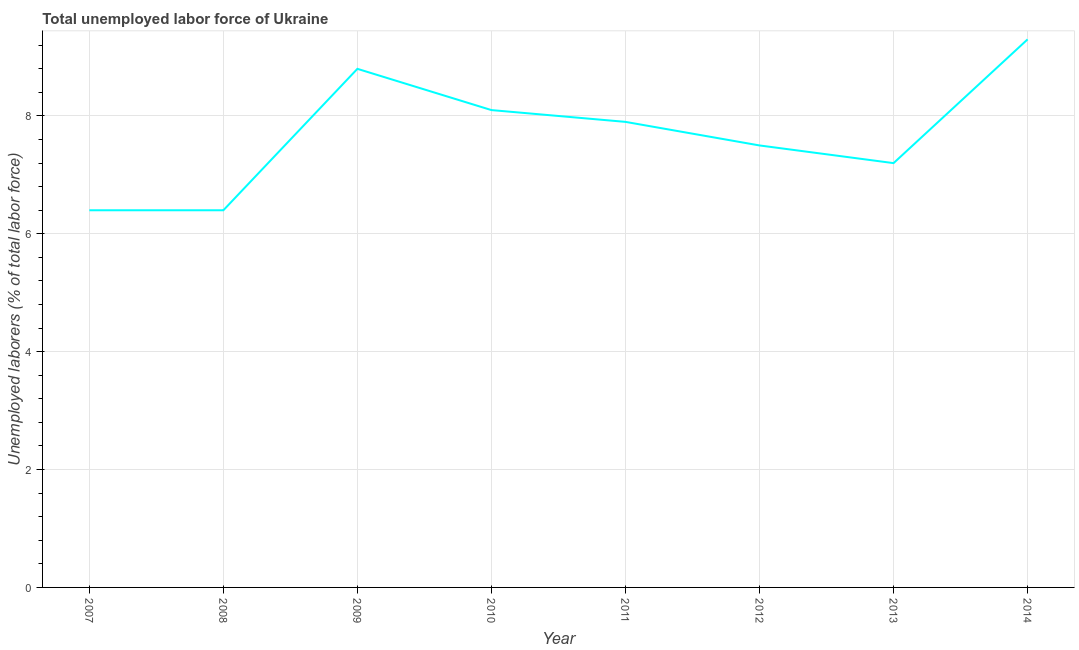What is the total unemployed labour force in 2013?
Your response must be concise. 7.2. Across all years, what is the maximum total unemployed labour force?
Ensure brevity in your answer.  9.3. Across all years, what is the minimum total unemployed labour force?
Provide a succinct answer. 6.4. In which year was the total unemployed labour force minimum?
Make the answer very short. 2007. What is the sum of the total unemployed labour force?
Your answer should be compact. 61.6. What is the difference between the total unemployed labour force in 2007 and 2010?
Make the answer very short. -1.7. What is the average total unemployed labour force per year?
Your response must be concise. 7.7. What is the median total unemployed labour force?
Make the answer very short. 7.7. In how many years, is the total unemployed labour force greater than 2.4 %?
Ensure brevity in your answer.  8. What is the ratio of the total unemployed labour force in 2008 to that in 2013?
Provide a succinct answer. 0.89. Is the difference between the total unemployed labour force in 2007 and 2008 greater than the difference between any two years?
Your answer should be compact. No. What is the difference between the highest and the second highest total unemployed labour force?
Keep it short and to the point. 0.5. What is the difference between the highest and the lowest total unemployed labour force?
Provide a succinct answer. 2.9. Does the total unemployed labour force monotonically increase over the years?
Your response must be concise. No. How many lines are there?
Keep it short and to the point. 1. How many years are there in the graph?
Provide a succinct answer. 8. What is the difference between two consecutive major ticks on the Y-axis?
Offer a terse response. 2. Are the values on the major ticks of Y-axis written in scientific E-notation?
Your response must be concise. No. What is the title of the graph?
Give a very brief answer. Total unemployed labor force of Ukraine. What is the label or title of the Y-axis?
Provide a succinct answer. Unemployed laborers (% of total labor force). What is the Unemployed laborers (% of total labor force) in 2007?
Give a very brief answer. 6.4. What is the Unemployed laborers (% of total labor force) of 2008?
Your answer should be very brief. 6.4. What is the Unemployed laborers (% of total labor force) in 2009?
Provide a short and direct response. 8.8. What is the Unemployed laborers (% of total labor force) in 2010?
Provide a succinct answer. 8.1. What is the Unemployed laborers (% of total labor force) of 2011?
Give a very brief answer. 7.9. What is the Unemployed laborers (% of total labor force) of 2013?
Make the answer very short. 7.2. What is the Unemployed laborers (% of total labor force) in 2014?
Keep it short and to the point. 9.3. What is the difference between the Unemployed laborers (% of total labor force) in 2007 and 2009?
Provide a short and direct response. -2.4. What is the difference between the Unemployed laborers (% of total labor force) in 2007 and 2013?
Give a very brief answer. -0.8. What is the difference between the Unemployed laborers (% of total labor force) in 2007 and 2014?
Make the answer very short. -2.9. What is the difference between the Unemployed laborers (% of total labor force) in 2008 and 2010?
Ensure brevity in your answer.  -1.7. What is the difference between the Unemployed laborers (% of total labor force) in 2008 and 2011?
Your answer should be compact. -1.5. What is the difference between the Unemployed laborers (% of total labor force) in 2008 and 2012?
Ensure brevity in your answer.  -1.1. What is the difference between the Unemployed laborers (% of total labor force) in 2008 and 2013?
Ensure brevity in your answer.  -0.8. What is the difference between the Unemployed laborers (% of total labor force) in 2009 and 2010?
Your answer should be very brief. 0.7. What is the difference between the Unemployed laborers (% of total labor force) in 2009 and 2011?
Your answer should be very brief. 0.9. What is the difference between the Unemployed laborers (% of total labor force) in 2009 and 2014?
Offer a terse response. -0.5. What is the difference between the Unemployed laborers (% of total labor force) in 2011 and 2012?
Offer a very short reply. 0.4. What is the difference between the Unemployed laborers (% of total labor force) in 2012 and 2013?
Provide a succinct answer. 0.3. What is the difference between the Unemployed laborers (% of total labor force) in 2012 and 2014?
Provide a succinct answer. -1.8. What is the difference between the Unemployed laborers (% of total labor force) in 2013 and 2014?
Your answer should be compact. -2.1. What is the ratio of the Unemployed laborers (% of total labor force) in 2007 to that in 2008?
Your response must be concise. 1. What is the ratio of the Unemployed laborers (% of total labor force) in 2007 to that in 2009?
Your answer should be compact. 0.73. What is the ratio of the Unemployed laborers (% of total labor force) in 2007 to that in 2010?
Your answer should be compact. 0.79. What is the ratio of the Unemployed laborers (% of total labor force) in 2007 to that in 2011?
Offer a very short reply. 0.81. What is the ratio of the Unemployed laborers (% of total labor force) in 2007 to that in 2012?
Ensure brevity in your answer.  0.85. What is the ratio of the Unemployed laborers (% of total labor force) in 2007 to that in 2013?
Make the answer very short. 0.89. What is the ratio of the Unemployed laborers (% of total labor force) in 2007 to that in 2014?
Make the answer very short. 0.69. What is the ratio of the Unemployed laborers (% of total labor force) in 2008 to that in 2009?
Provide a short and direct response. 0.73. What is the ratio of the Unemployed laborers (% of total labor force) in 2008 to that in 2010?
Your answer should be compact. 0.79. What is the ratio of the Unemployed laborers (% of total labor force) in 2008 to that in 2011?
Your response must be concise. 0.81. What is the ratio of the Unemployed laborers (% of total labor force) in 2008 to that in 2012?
Offer a very short reply. 0.85. What is the ratio of the Unemployed laborers (% of total labor force) in 2008 to that in 2013?
Provide a succinct answer. 0.89. What is the ratio of the Unemployed laborers (% of total labor force) in 2008 to that in 2014?
Provide a short and direct response. 0.69. What is the ratio of the Unemployed laborers (% of total labor force) in 2009 to that in 2010?
Keep it short and to the point. 1.09. What is the ratio of the Unemployed laborers (% of total labor force) in 2009 to that in 2011?
Offer a very short reply. 1.11. What is the ratio of the Unemployed laborers (% of total labor force) in 2009 to that in 2012?
Your answer should be compact. 1.17. What is the ratio of the Unemployed laborers (% of total labor force) in 2009 to that in 2013?
Your response must be concise. 1.22. What is the ratio of the Unemployed laborers (% of total labor force) in 2009 to that in 2014?
Offer a very short reply. 0.95. What is the ratio of the Unemployed laborers (% of total labor force) in 2010 to that in 2011?
Give a very brief answer. 1.02. What is the ratio of the Unemployed laborers (% of total labor force) in 2010 to that in 2012?
Offer a terse response. 1.08. What is the ratio of the Unemployed laborers (% of total labor force) in 2010 to that in 2013?
Your answer should be very brief. 1.12. What is the ratio of the Unemployed laborers (% of total labor force) in 2010 to that in 2014?
Give a very brief answer. 0.87. What is the ratio of the Unemployed laborers (% of total labor force) in 2011 to that in 2012?
Provide a succinct answer. 1.05. What is the ratio of the Unemployed laborers (% of total labor force) in 2011 to that in 2013?
Ensure brevity in your answer.  1.1. What is the ratio of the Unemployed laborers (% of total labor force) in 2011 to that in 2014?
Give a very brief answer. 0.85. What is the ratio of the Unemployed laborers (% of total labor force) in 2012 to that in 2013?
Give a very brief answer. 1.04. What is the ratio of the Unemployed laborers (% of total labor force) in 2012 to that in 2014?
Offer a very short reply. 0.81. What is the ratio of the Unemployed laborers (% of total labor force) in 2013 to that in 2014?
Offer a very short reply. 0.77. 